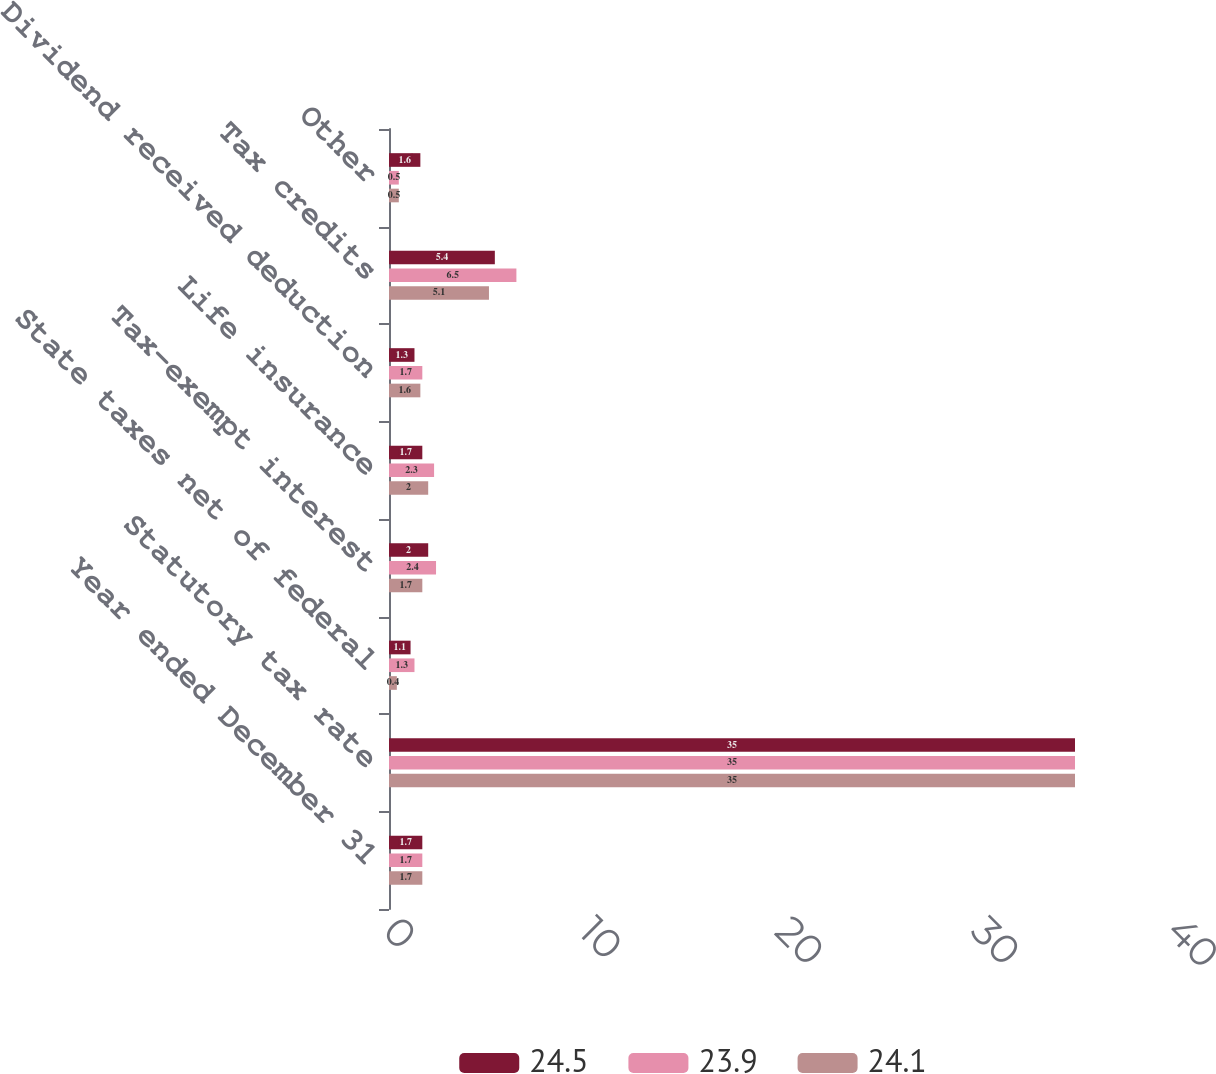Convert chart to OTSL. <chart><loc_0><loc_0><loc_500><loc_500><stacked_bar_chart><ecel><fcel>Year ended December 31<fcel>Statutory tax rate<fcel>State taxes net of federal<fcel>Tax-exempt interest<fcel>Life insurance<fcel>Dividend received deduction<fcel>Tax credits<fcel>Other<nl><fcel>24.5<fcel>1.7<fcel>35<fcel>1.1<fcel>2<fcel>1.7<fcel>1.3<fcel>5.4<fcel>1.6<nl><fcel>23.9<fcel>1.7<fcel>35<fcel>1.3<fcel>2.4<fcel>2.3<fcel>1.7<fcel>6.5<fcel>0.5<nl><fcel>24.1<fcel>1.7<fcel>35<fcel>0.4<fcel>1.7<fcel>2<fcel>1.6<fcel>5.1<fcel>0.5<nl></chart> 